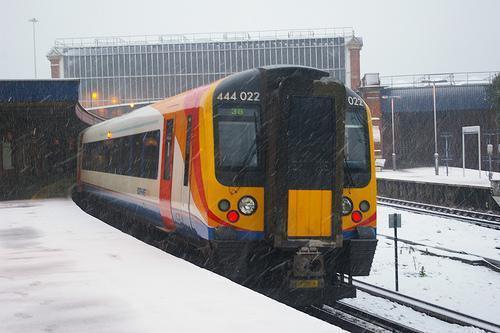How many people are shown?
Give a very brief answer. 0. How many trains are shown?
Give a very brief answer. 1. How many lights on the train?
Give a very brief answer. 6. 